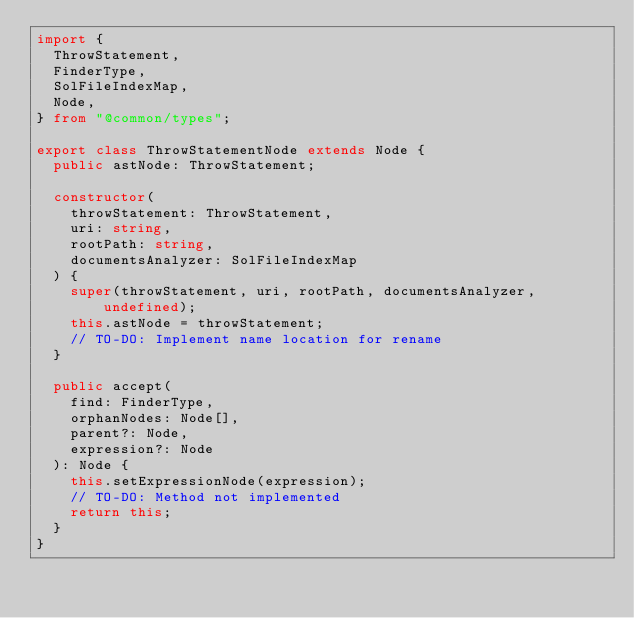Convert code to text. <code><loc_0><loc_0><loc_500><loc_500><_TypeScript_>import {
  ThrowStatement,
  FinderType,
  SolFileIndexMap,
  Node,
} from "@common/types";

export class ThrowStatementNode extends Node {
  public astNode: ThrowStatement;

  constructor(
    throwStatement: ThrowStatement,
    uri: string,
    rootPath: string,
    documentsAnalyzer: SolFileIndexMap
  ) {
    super(throwStatement, uri, rootPath, documentsAnalyzer, undefined);
    this.astNode = throwStatement;
    // TO-DO: Implement name location for rename
  }

  public accept(
    find: FinderType,
    orphanNodes: Node[],
    parent?: Node,
    expression?: Node
  ): Node {
    this.setExpressionNode(expression);
    // TO-DO: Method not implemented
    return this;
  }
}
</code> 